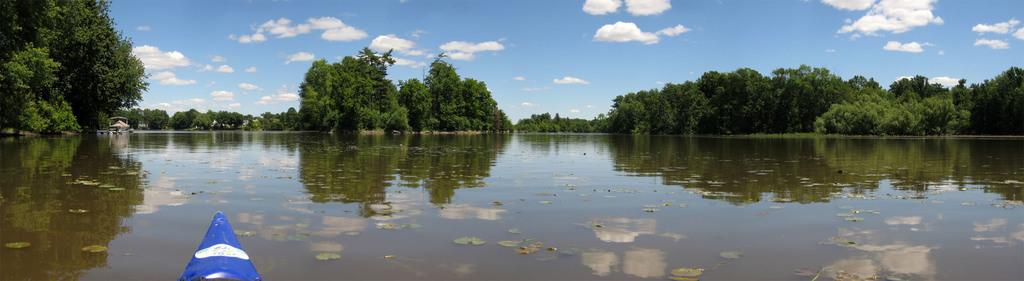What is the primary element in the image? There is water in the image. What can be found floating in the water? There are leaves and objects in the water. What is the source of the objects in the water? The objects in the water are likely from the trees, as there are trees in the image. What is visible in the water due to the trees? The reflection of trees is visible in the water. What is visible in the background of the image? The sky is visible in the image, and there are clouds in the sky. How many goldfish can be seen swimming in the water in the image? There are no goldfish visible in the water in the image. What is the cause of the reflection of the trees in the water? The reflection of the trees in the water is caused by the water's surface acting as a mirror, reflecting the image of the trees above it. 